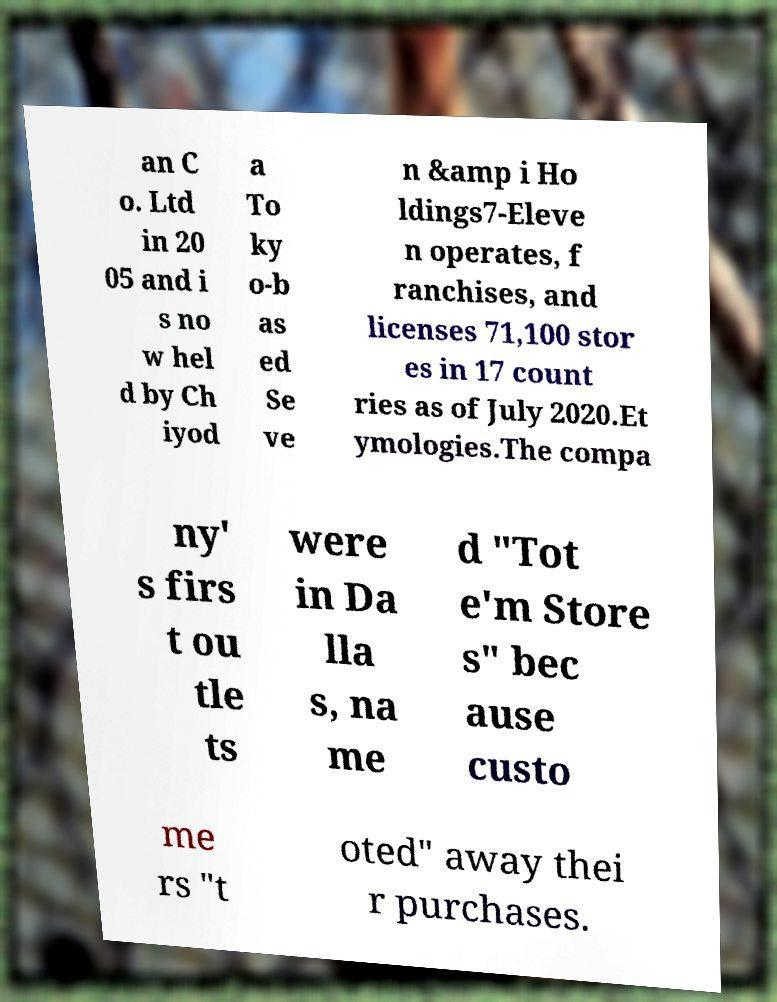For documentation purposes, I need the text within this image transcribed. Could you provide that? an C o. Ltd in 20 05 and i s no w hel d by Ch iyod a To ky o-b as ed Se ve n &amp i Ho ldings7-Eleve n operates, f ranchises, and licenses 71,100 stor es in 17 count ries as of July 2020.Et ymologies.The compa ny' s firs t ou tle ts were in Da lla s, na me d "Tot e'm Store s" bec ause custo me rs "t oted" away thei r purchases. 